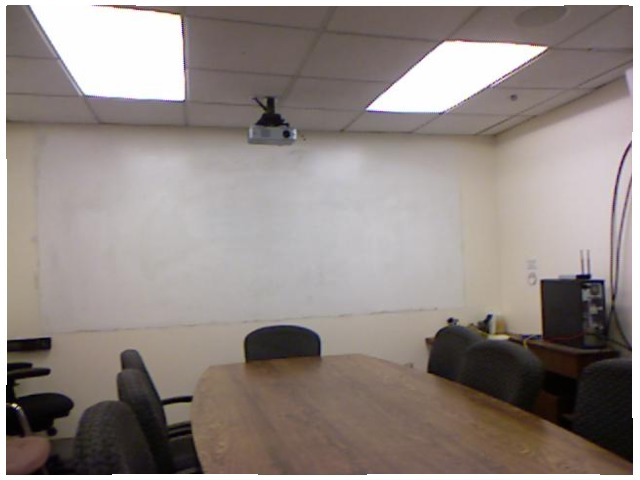<image>
Can you confirm if the projector is above the table? Yes. The projector is positioned above the table in the vertical space, higher up in the scene. Is the white board on the wall? Yes. Looking at the image, I can see the white board is positioned on top of the wall, with the wall providing support. Where is the computer in relation to the table? Is it on the table? No. The computer is not positioned on the table. They may be near each other, but the computer is not supported by or resting on top of the table. Is there a chair on the table? No. The chair is not positioned on the table. They may be near each other, but the chair is not supported by or resting on top of the table. Is the projector behind the chair? No. The projector is not behind the chair. From this viewpoint, the projector appears to be positioned elsewhere in the scene. 